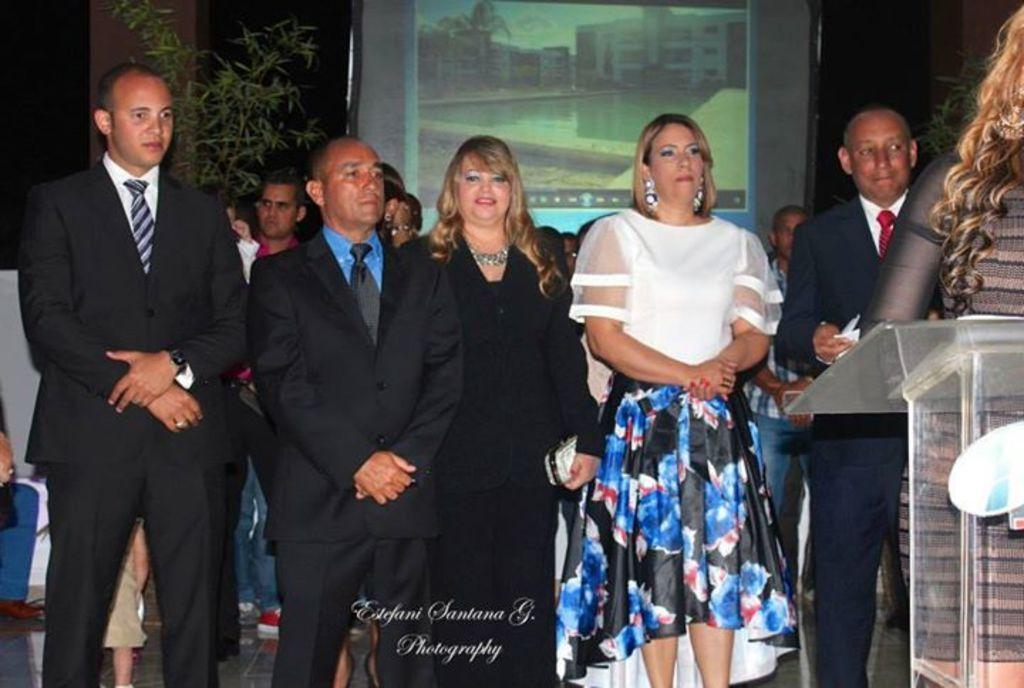How would you summarize this image in a sentence or two? In the picture there are a group of people standing and on the right side there is some table, behind them there is a projector screen and something is being displayed on the screen, on the left side there is a plant. 